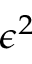<formula> <loc_0><loc_0><loc_500><loc_500>\epsilon ^ { 2 }</formula> 